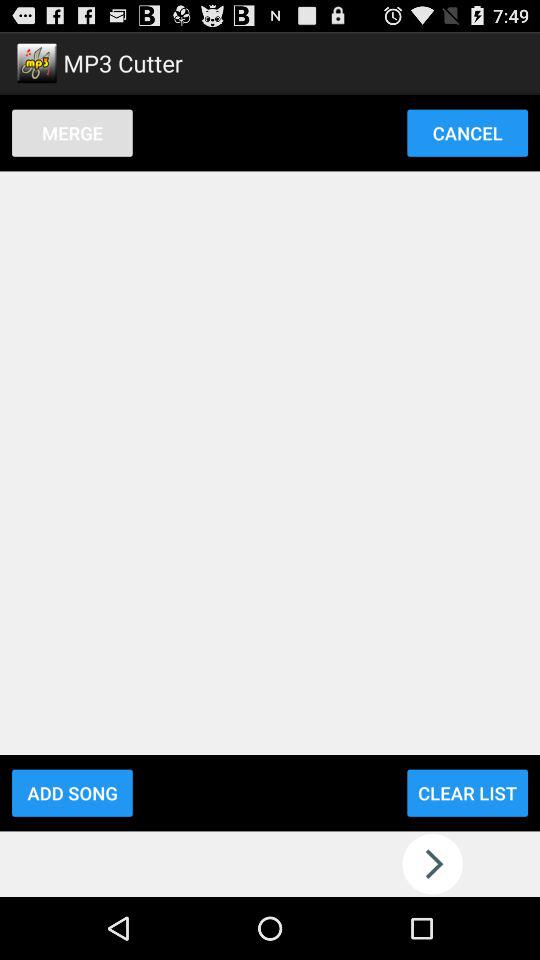What is the name of the application? The name of the application is "MP3 Cutter". 